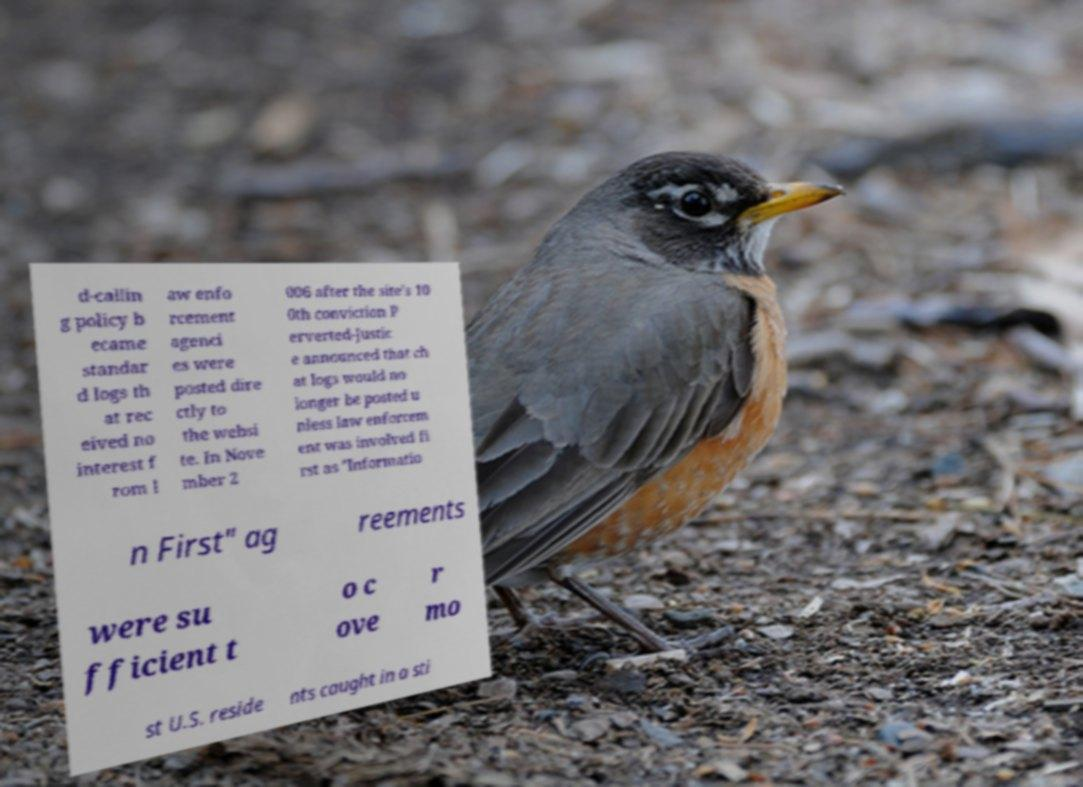Please identify and transcribe the text found in this image. d-callin g policy b ecame standar d logs th at rec eived no interest f rom l aw enfo rcement agenci es were posted dire ctly to the websi te. In Nove mber 2 006 after the site's 10 0th conviction P erverted-Justic e announced that ch at logs would no longer be posted u nless law enforcem ent was involved fi rst as "Informatio n First" ag reements were su fficient t o c ove r mo st U.S. reside nts caught in a sti 